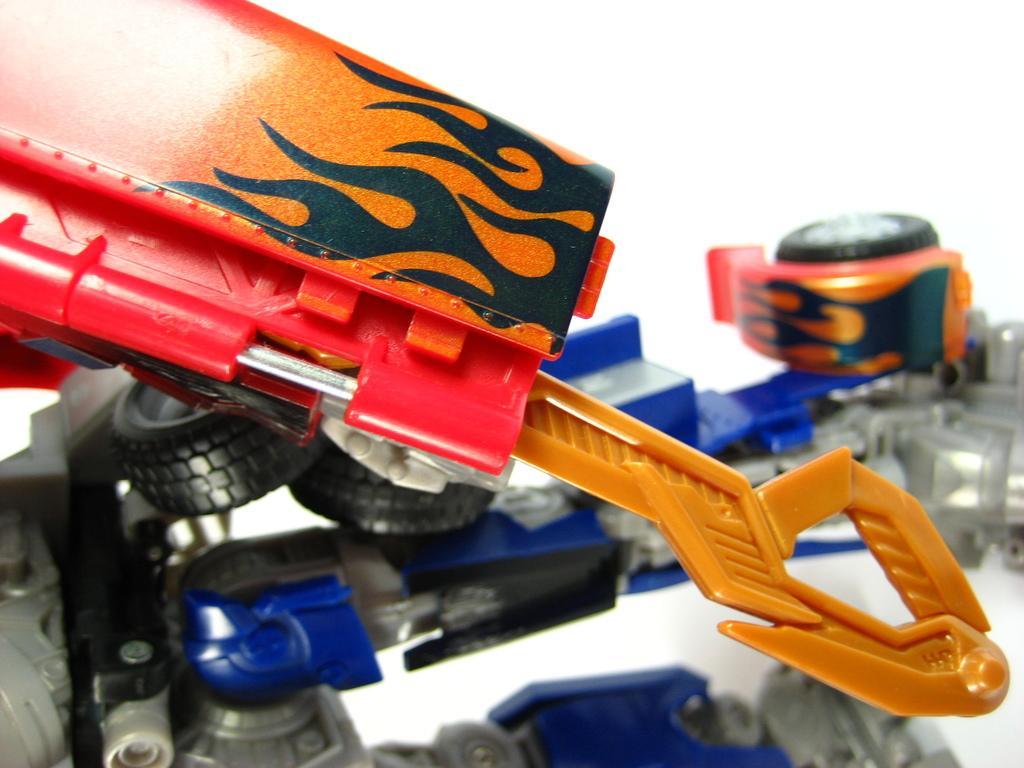Can you describe this image briefly? In the foreground of this image, there is a toy crane and there is another toy in the background and the white plane background. 